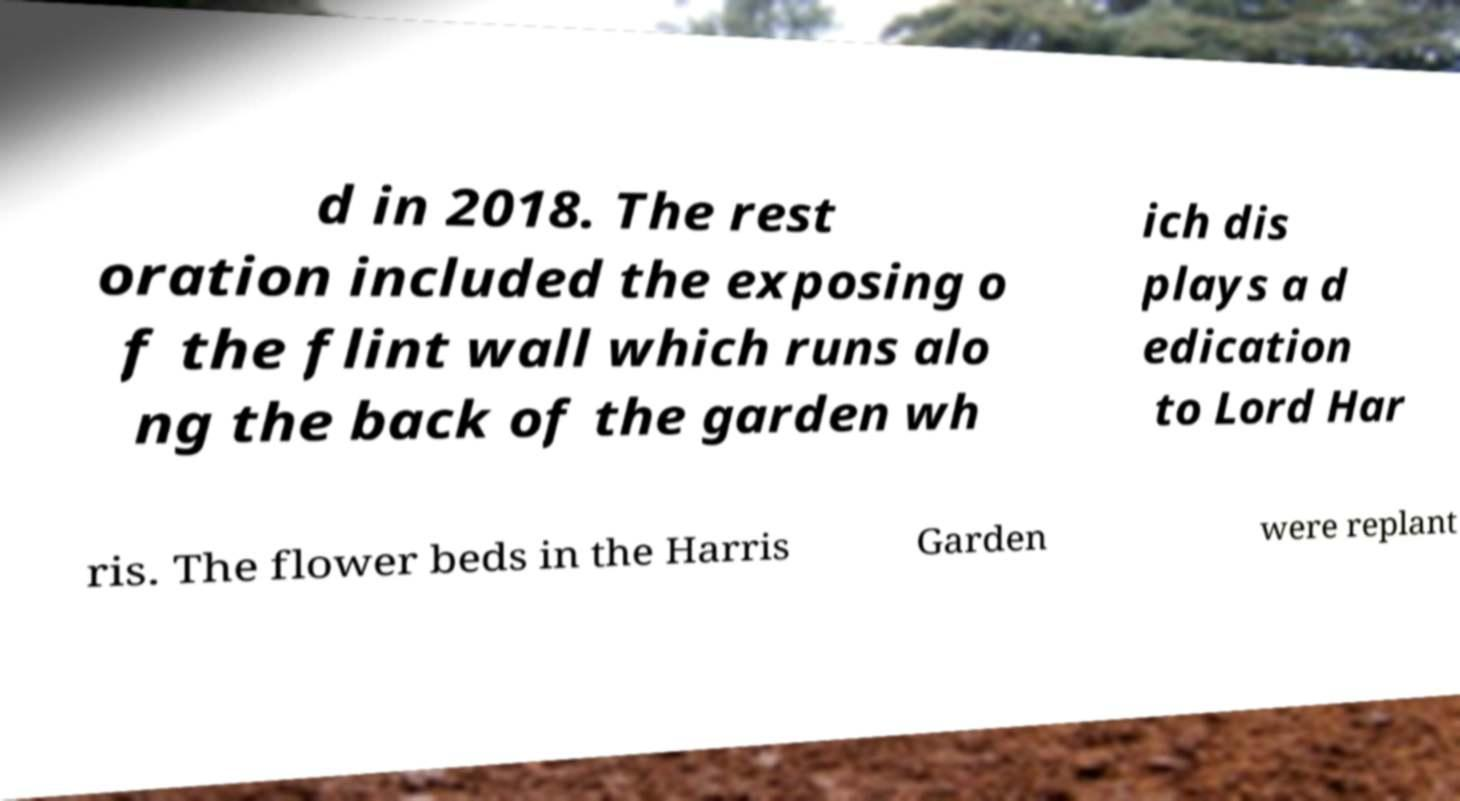There's text embedded in this image that I need extracted. Can you transcribe it verbatim? d in 2018. The rest oration included the exposing o f the flint wall which runs alo ng the back of the garden wh ich dis plays a d edication to Lord Har ris. The flower beds in the Harris Garden were replant 